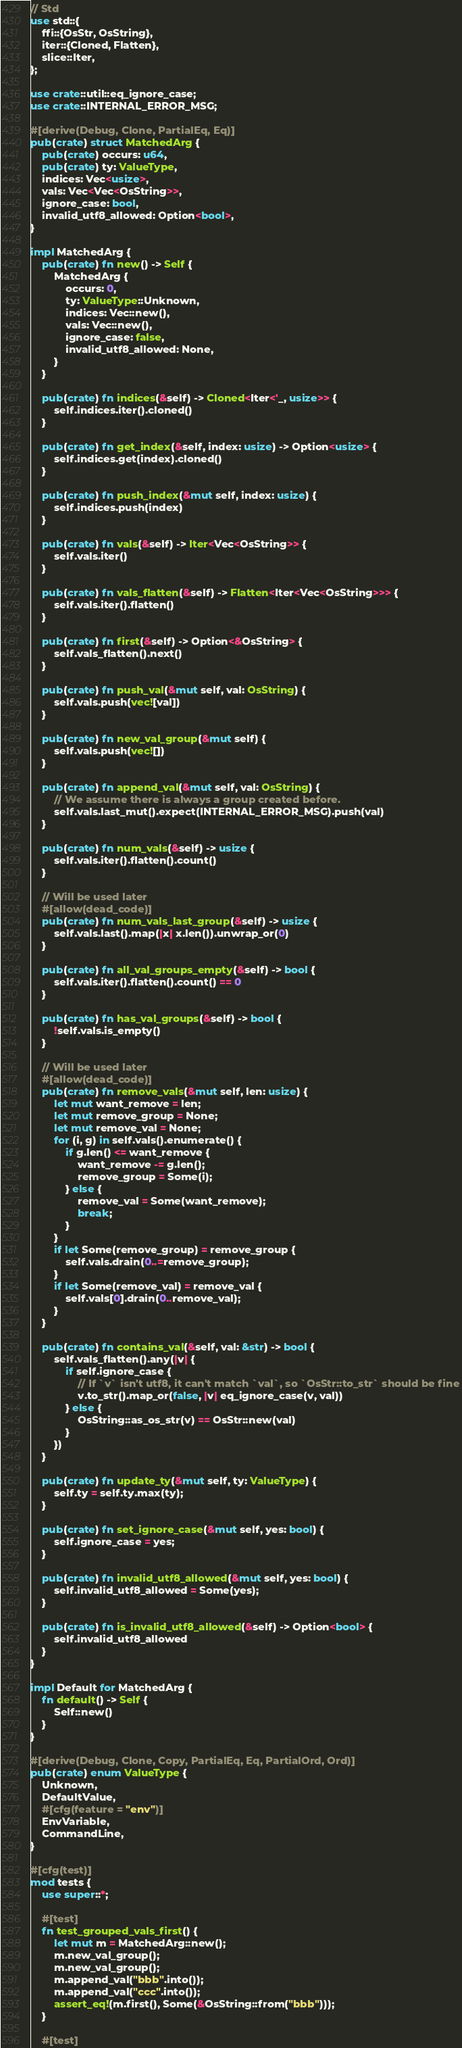<code> <loc_0><loc_0><loc_500><loc_500><_Rust_>// Std
use std::{
    ffi::{OsStr, OsString},
    iter::{Cloned, Flatten},
    slice::Iter,
};

use crate::util::eq_ignore_case;
use crate::INTERNAL_ERROR_MSG;

#[derive(Debug, Clone, PartialEq, Eq)]
pub(crate) struct MatchedArg {
    pub(crate) occurs: u64,
    pub(crate) ty: ValueType,
    indices: Vec<usize>,
    vals: Vec<Vec<OsString>>,
    ignore_case: bool,
    invalid_utf8_allowed: Option<bool>,
}

impl MatchedArg {
    pub(crate) fn new() -> Self {
        MatchedArg {
            occurs: 0,
            ty: ValueType::Unknown,
            indices: Vec::new(),
            vals: Vec::new(),
            ignore_case: false,
            invalid_utf8_allowed: None,
        }
    }

    pub(crate) fn indices(&self) -> Cloned<Iter<'_, usize>> {
        self.indices.iter().cloned()
    }

    pub(crate) fn get_index(&self, index: usize) -> Option<usize> {
        self.indices.get(index).cloned()
    }

    pub(crate) fn push_index(&mut self, index: usize) {
        self.indices.push(index)
    }

    pub(crate) fn vals(&self) -> Iter<Vec<OsString>> {
        self.vals.iter()
    }

    pub(crate) fn vals_flatten(&self) -> Flatten<Iter<Vec<OsString>>> {
        self.vals.iter().flatten()
    }

    pub(crate) fn first(&self) -> Option<&OsString> {
        self.vals_flatten().next()
    }

    pub(crate) fn push_val(&mut self, val: OsString) {
        self.vals.push(vec![val])
    }

    pub(crate) fn new_val_group(&mut self) {
        self.vals.push(vec![])
    }

    pub(crate) fn append_val(&mut self, val: OsString) {
        // We assume there is always a group created before.
        self.vals.last_mut().expect(INTERNAL_ERROR_MSG).push(val)
    }

    pub(crate) fn num_vals(&self) -> usize {
        self.vals.iter().flatten().count()
    }

    // Will be used later
    #[allow(dead_code)]
    pub(crate) fn num_vals_last_group(&self) -> usize {
        self.vals.last().map(|x| x.len()).unwrap_or(0)
    }

    pub(crate) fn all_val_groups_empty(&self) -> bool {
        self.vals.iter().flatten().count() == 0
    }

    pub(crate) fn has_val_groups(&self) -> bool {
        !self.vals.is_empty()
    }

    // Will be used later
    #[allow(dead_code)]
    pub(crate) fn remove_vals(&mut self, len: usize) {
        let mut want_remove = len;
        let mut remove_group = None;
        let mut remove_val = None;
        for (i, g) in self.vals().enumerate() {
            if g.len() <= want_remove {
                want_remove -= g.len();
                remove_group = Some(i);
            } else {
                remove_val = Some(want_remove);
                break;
            }
        }
        if let Some(remove_group) = remove_group {
            self.vals.drain(0..=remove_group);
        }
        if let Some(remove_val) = remove_val {
            self.vals[0].drain(0..remove_val);
        }
    }

    pub(crate) fn contains_val(&self, val: &str) -> bool {
        self.vals_flatten().any(|v| {
            if self.ignore_case {
                // If `v` isn't utf8, it can't match `val`, so `OsStr::to_str` should be fine
                v.to_str().map_or(false, |v| eq_ignore_case(v, val))
            } else {
                OsString::as_os_str(v) == OsStr::new(val)
            }
        })
    }

    pub(crate) fn update_ty(&mut self, ty: ValueType) {
        self.ty = self.ty.max(ty);
    }

    pub(crate) fn set_ignore_case(&mut self, yes: bool) {
        self.ignore_case = yes;
    }

    pub(crate) fn invalid_utf8_allowed(&mut self, yes: bool) {
        self.invalid_utf8_allowed = Some(yes);
    }

    pub(crate) fn is_invalid_utf8_allowed(&self) -> Option<bool> {
        self.invalid_utf8_allowed
    }
}

impl Default for MatchedArg {
    fn default() -> Self {
        Self::new()
    }
}

#[derive(Debug, Clone, Copy, PartialEq, Eq, PartialOrd, Ord)]
pub(crate) enum ValueType {
    Unknown,
    DefaultValue,
    #[cfg(feature = "env")]
    EnvVariable,
    CommandLine,
}

#[cfg(test)]
mod tests {
    use super::*;

    #[test]
    fn test_grouped_vals_first() {
        let mut m = MatchedArg::new();
        m.new_val_group();
        m.new_val_group();
        m.append_val("bbb".into());
        m.append_val("ccc".into());
        assert_eq!(m.first(), Some(&OsString::from("bbb")));
    }

    #[test]</code> 